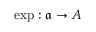<formula> <loc_0><loc_0><loc_500><loc_500>\exp \colon { \mathfrak { a } } \to A</formula> 